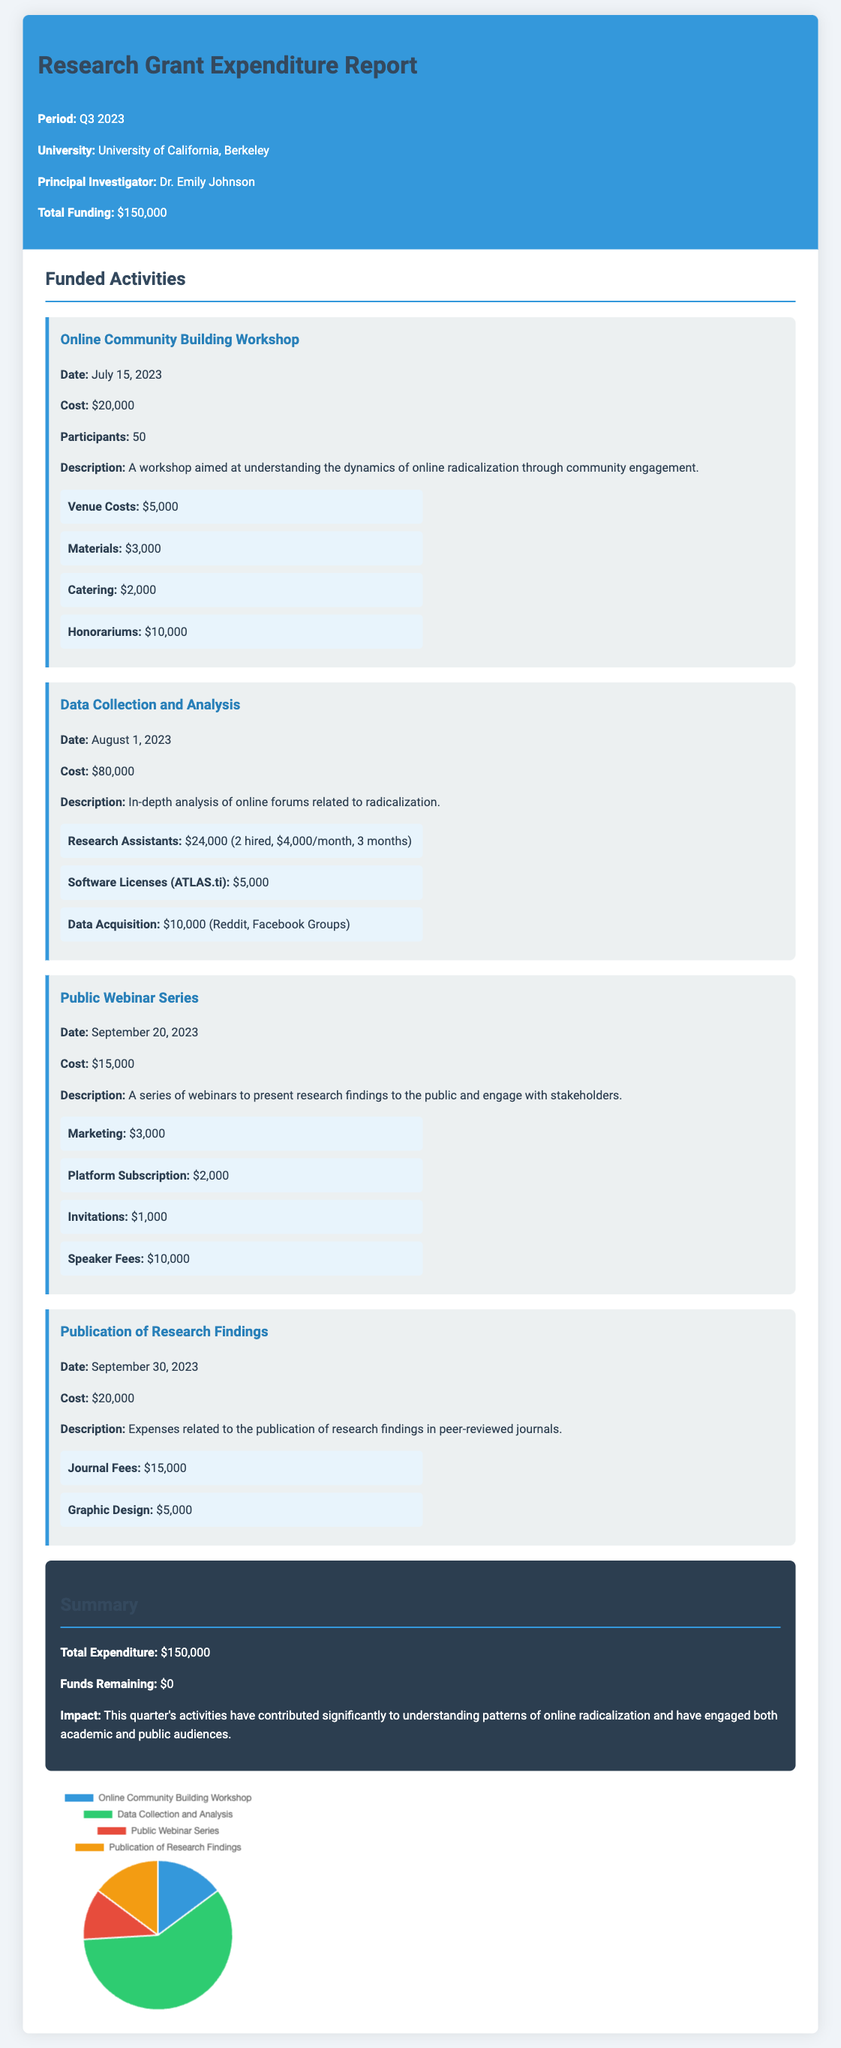What is the total funding? The total funding is stated at the beginning of the document, which is $150,000.
Answer: $150,000 Who is the Principal Investigator? The Principal Investigator is introduced in the header of the report, which is Dr. Emily Johnson.
Answer: Dr. Emily Johnson What was the cost of the Data Collection and Analysis activity? The cost for the Data Collection and Analysis activity is specified in the activity section, which is $80,000.
Answer: $80,000 How many participants attended the Online Community Building Workshop? The number of participants is mentioned in the details of the Online Community Building Workshop, which is 50.
Answer: 50 What expense category for the Publication of Research Findings was the most expensive? The most expensive category in the Publication of Research Findings is identified as Journal Fees in the expense breakdown.
Answer: Journal Fees What was the total expenditure for the quarter? The total expenditure is summarized in the report, which sums up to $150,000.
Answer: $150,000 Which activity had the highest cost? Analyzing the costs listed, the Data Collection and Analysis activity had the highest cost at $80,000.
Answer: Data Collection and Analysis What is the impact mentioned in the summary? The report summarizes the impact of the activities as contributing significantly to understanding patterns of online radicalization.
Answer: Understanding patterns of online radicalization What was the date of the Public Webinar Series? The date for the Public Webinar Series is mentioned within the activity details, which is September 20, 2023.
Answer: September 20, 2023 How much was spent on catering for the Online Community Building Workshop? The document lists catering costs for the Online Community Building Workshop, which is $2,000.
Answer: $2,000 